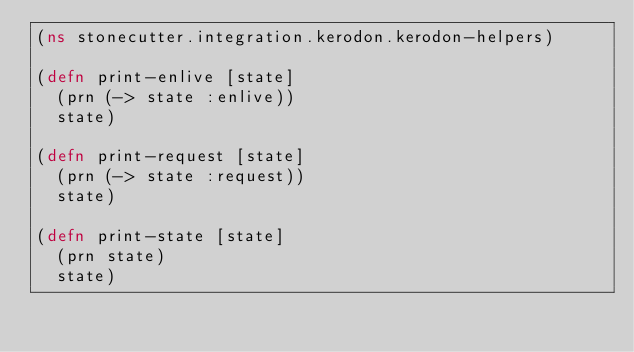Convert code to text. <code><loc_0><loc_0><loc_500><loc_500><_Clojure_>(ns stonecutter.integration.kerodon.kerodon-helpers)

(defn print-enlive [state]
  (prn (-> state :enlive))
  state)

(defn print-request [state]
  (prn (-> state :request))
  state)

(defn print-state [state]
  (prn state)
  state)
</code> 